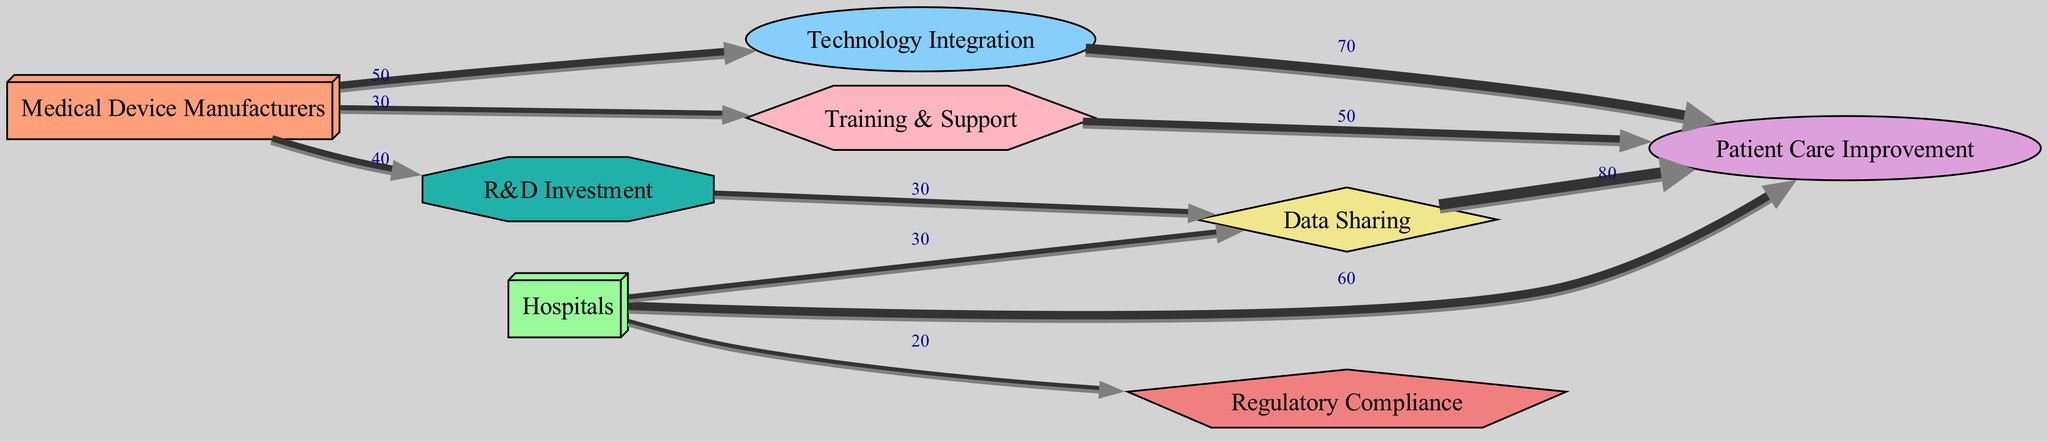What is the total value flowing into Patient Care Improvement? To find the total value flowing into the "Patient Care Improvement" node, we look at all the links directed towards it. The contributing values are: 70 from "Technology Integration", 80 from "Data Sharing", and 50 from "Training & Support". Adding these together gives us 70 + 80 + 50 = 200.
Answer: 200 How many nodes are represented in this diagram? Counting all the unique entities listed under "nodes", we find the following: Medical Device Manufacturers, Hospitals, Technology Integration, Patient Care Improvement, Data Sharing, Regulatory Compliance, R&D Investment, and Training & Support. This totals up to 8 nodes.
Answer: 8 Which node has the highest outgoing value? Observing the outgoing links from each node, "Data Sharing" has an outgoing value of 80 to "Patient Care Improvement", which is the highest compared to other nodes like "Medical Device Manufacturers" and "Hospitals". Therefore, "Data Sharing" is the one with the highest outgoing value.
Answer: Data Sharing What percentage of the total contributions to Patient Care Improvement comes from Data Sharing? The total contributions to "Patient Care Improvement" amount to 200. The contribution from "Data Sharing" is 80. To find the percentage, we calculate (80/200) * 100% = 40%.
Answer: 40% Which is the least contributing node? After reviewing the links, "Hospitals" contributes the least with a value of 20 to "Regulatory Compliance". Since it is the lowest single value from any node, we can conclude that "Hospitals" has the least contribution overall.
Answer: Hospitals What is the combined value of contributions from Medical Device Manufacturers? The "Medical Device Manufacturers" have three outgoing links with the values: 50 to "Technology Integration", 40 to "R&D Investment", and 30 to "Training & Support". Adding these values together (50 + 40 + 30) results in a total of 120.
Answer: 120 How does the contribution from R&D Investment to Data Sharing compare to the contribution from Technology Integration to Patient Care Improvement? The contribution from "R&D Investment" to "Data Sharing" is 30, whereas the contribution from "Technology Integration" to "Patient Care Improvement" is 70. Comparing these, 70 is clearly greater than 30, indicating that "Technology Integration" contributes significantly more.
Answer: 70 is greater than 30 How many total outgoing contributions flow from Hospitals? The "Hospitals" node has two outgoing contributions: 60 to "Patient Care Improvement" and 20 to "Regulatory Compliance". Thus, the total number of outgoing contributions from "Hospitals" is 2.
Answer: 2 